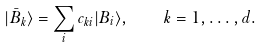Convert formula to latex. <formula><loc_0><loc_0><loc_500><loc_500>| \bar { B } _ { k } \rangle = \sum _ { i } c _ { k i } | B _ { i } \rangle , \quad k = 1 , \dots , d .</formula> 